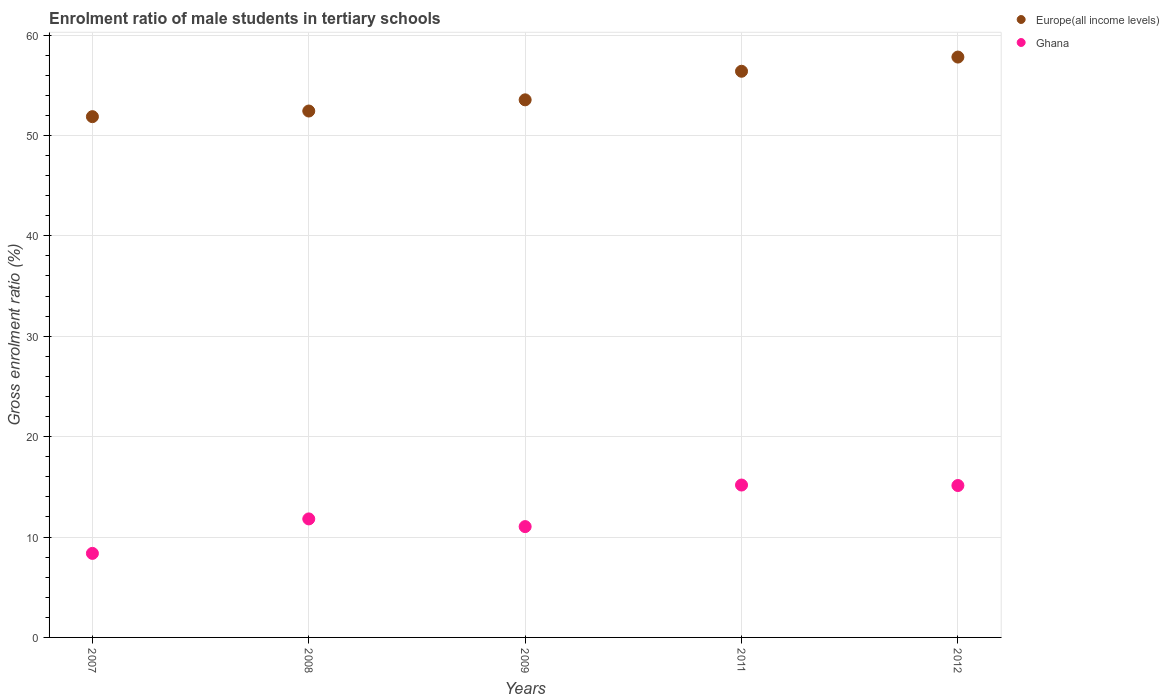What is the enrolment ratio of male students in tertiary schools in Europe(all income levels) in 2011?
Keep it short and to the point. 56.39. Across all years, what is the maximum enrolment ratio of male students in tertiary schools in Europe(all income levels)?
Provide a succinct answer. 57.81. Across all years, what is the minimum enrolment ratio of male students in tertiary schools in Europe(all income levels)?
Make the answer very short. 51.87. In which year was the enrolment ratio of male students in tertiary schools in Europe(all income levels) maximum?
Offer a very short reply. 2012. What is the total enrolment ratio of male students in tertiary schools in Ghana in the graph?
Your answer should be compact. 61.52. What is the difference between the enrolment ratio of male students in tertiary schools in Europe(all income levels) in 2008 and that in 2012?
Provide a succinct answer. -5.37. What is the difference between the enrolment ratio of male students in tertiary schools in Europe(all income levels) in 2009 and the enrolment ratio of male students in tertiary schools in Ghana in 2007?
Provide a short and direct response. 45.18. What is the average enrolment ratio of male students in tertiary schools in Ghana per year?
Provide a short and direct response. 12.3. In the year 2007, what is the difference between the enrolment ratio of male students in tertiary schools in Ghana and enrolment ratio of male students in tertiary schools in Europe(all income levels)?
Your answer should be compact. -43.5. What is the ratio of the enrolment ratio of male students in tertiary schools in Europe(all income levels) in 2007 to that in 2011?
Your answer should be compact. 0.92. What is the difference between the highest and the second highest enrolment ratio of male students in tertiary schools in Europe(all income levels)?
Your response must be concise. 1.41. What is the difference between the highest and the lowest enrolment ratio of male students in tertiary schools in Europe(all income levels)?
Give a very brief answer. 5.94. In how many years, is the enrolment ratio of male students in tertiary schools in Europe(all income levels) greater than the average enrolment ratio of male students in tertiary schools in Europe(all income levels) taken over all years?
Ensure brevity in your answer.  2. Does the enrolment ratio of male students in tertiary schools in Europe(all income levels) monotonically increase over the years?
Keep it short and to the point. Yes. Is the enrolment ratio of male students in tertiary schools in Europe(all income levels) strictly greater than the enrolment ratio of male students in tertiary schools in Ghana over the years?
Keep it short and to the point. Yes. How many dotlines are there?
Your response must be concise. 2. How many years are there in the graph?
Offer a very short reply. 5. Does the graph contain any zero values?
Offer a very short reply. No. Does the graph contain grids?
Your answer should be compact. Yes. Where does the legend appear in the graph?
Give a very brief answer. Top right. How many legend labels are there?
Your answer should be very brief. 2. What is the title of the graph?
Give a very brief answer. Enrolment ratio of male students in tertiary schools. What is the label or title of the X-axis?
Keep it short and to the point. Years. What is the label or title of the Y-axis?
Offer a very short reply. Gross enrolment ratio (%). What is the Gross enrolment ratio (%) of Europe(all income levels) in 2007?
Provide a succinct answer. 51.87. What is the Gross enrolment ratio (%) of Ghana in 2007?
Provide a succinct answer. 8.37. What is the Gross enrolment ratio (%) in Europe(all income levels) in 2008?
Offer a terse response. 52.43. What is the Gross enrolment ratio (%) of Ghana in 2008?
Make the answer very short. 11.8. What is the Gross enrolment ratio (%) in Europe(all income levels) in 2009?
Offer a terse response. 53.55. What is the Gross enrolment ratio (%) in Ghana in 2009?
Offer a very short reply. 11.04. What is the Gross enrolment ratio (%) of Europe(all income levels) in 2011?
Your response must be concise. 56.39. What is the Gross enrolment ratio (%) in Ghana in 2011?
Your answer should be compact. 15.18. What is the Gross enrolment ratio (%) in Europe(all income levels) in 2012?
Offer a very short reply. 57.81. What is the Gross enrolment ratio (%) in Ghana in 2012?
Offer a very short reply. 15.13. Across all years, what is the maximum Gross enrolment ratio (%) in Europe(all income levels)?
Keep it short and to the point. 57.81. Across all years, what is the maximum Gross enrolment ratio (%) in Ghana?
Offer a very short reply. 15.18. Across all years, what is the minimum Gross enrolment ratio (%) in Europe(all income levels)?
Provide a succinct answer. 51.87. Across all years, what is the minimum Gross enrolment ratio (%) in Ghana?
Provide a succinct answer. 8.37. What is the total Gross enrolment ratio (%) in Europe(all income levels) in the graph?
Offer a terse response. 272.05. What is the total Gross enrolment ratio (%) of Ghana in the graph?
Ensure brevity in your answer.  61.52. What is the difference between the Gross enrolment ratio (%) of Europe(all income levels) in 2007 and that in 2008?
Provide a succinct answer. -0.56. What is the difference between the Gross enrolment ratio (%) in Ghana in 2007 and that in 2008?
Your response must be concise. -3.43. What is the difference between the Gross enrolment ratio (%) in Europe(all income levels) in 2007 and that in 2009?
Provide a short and direct response. -1.68. What is the difference between the Gross enrolment ratio (%) in Ghana in 2007 and that in 2009?
Provide a short and direct response. -2.67. What is the difference between the Gross enrolment ratio (%) of Europe(all income levels) in 2007 and that in 2011?
Your answer should be compact. -4.52. What is the difference between the Gross enrolment ratio (%) in Ghana in 2007 and that in 2011?
Provide a short and direct response. -6.81. What is the difference between the Gross enrolment ratio (%) of Europe(all income levels) in 2007 and that in 2012?
Provide a succinct answer. -5.94. What is the difference between the Gross enrolment ratio (%) in Ghana in 2007 and that in 2012?
Your answer should be very brief. -6.76. What is the difference between the Gross enrolment ratio (%) in Europe(all income levels) in 2008 and that in 2009?
Provide a short and direct response. -1.11. What is the difference between the Gross enrolment ratio (%) of Ghana in 2008 and that in 2009?
Keep it short and to the point. 0.77. What is the difference between the Gross enrolment ratio (%) in Europe(all income levels) in 2008 and that in 2011?
Ensure brevity in your answer.  -3.96. What is the difference between the Gross enrolment ratio (%) of Ghana in 2008 and that in 2011?
Provide a short and direct response. -3.37. What is the difference between the Gross enrolment ratio (%) in Europe(all income levels) in 2008 and that in 2012?
Your response must be concise. -5.37. What is the difference between the Gross enrolment ratio (%) of Ghana in 2008 and that in 2012?
Your answer should be very brief. -3.33. What is the difference between the Gross enrolment ratio (%) of Europe(all income levels) in 2009 and that in 2011?
Offer a very short reply. -2.85. What is the difference between the Gross enrolment ratio (%) of Ghana in 2009 and that in 2011?
Provide a succinct answer. -4.14. What is the difference between the Gross enrolment ratio (%) of Europe(all income levels) in 2009 and that in 2012?
Keep it short and to the point. -4.26. What is the difference between the Gross enrolment ratio (%) of Ghana in 2009 and that in 2012?
Your answer should be compact. -4.09. What is the difference between the Gross enrolment ratio (%) in Europe(all income levels) in 2011 and that in 2012?
Make the answer very short. -1.41. What is the difference between the Gross enrolment ratio (%) of Ghana in 2011 and that in 2012?
Your answer should be very brief. 0.05. What is the difference between the Gross enrolment ratio (%) of Europe(all income levels) in 2007 and the Gross enrolment ratio (%) of Ghana in 2008?
Your response must be concise. 40.07. What is the difference between the Gross enrolment ratio (%) of Europe(all income levels) in 2007 and the Gross enrolment ratio (%) of Ghana in 2009?
Provide a succinct answer. 40.83. What is the difference between the Gross enrolment ratio (%) in Europe(all income levels) in 2007 and the Gross enrolment ratio (%) in Ghana in 2011?
Give a very brief answer. 36.69. What is the difference between the Gross enrolment ratio (%) of Europe(all income levels) in 2007 and the Gross enrolment ratio (%) of Ghana in 2012?
Keep it short and to the point. 36.74. What is the difference between the Gross enrolment ratio (%) in Europe(all income levels) in 2008 and the Gross enrolment ratio (%) in Ghana in 2009?
Give a very brief answer. 41.39. What is the difference between the Gross enrolment ratio (%) in Europe(all income levels) in 2008 and the Gross enrolment ratio (%) in Ghana in 2011?
Your answer should be very brief. 37.25. What is the difference between the Gross enrolment ratio (%) of Europe(all income levels) in 2008 and the Gross enrolment ratio (%) of Ghana in 2012?
Your response must be concise. 37.3. What is the difference between the Gross enrolment ratio (%) in Europe(all income levels) in 2009 and the Gross enrolment ratio (%) in Ghana in 2011?
Your answer should be very brief. 38.37. What is the difference between the Gross enrolment ratio (%) of Europe(all income levels) in 2009 and the Gross enrolment ratio (%) of Ghana in 2012?
Make the answer very short. 38.42. What is the difference between the Gross enrolment ratio (%) of Europe(all income levels) in 2011 and the Gross enrolment ratio (%) of Ghana in 2012?
Ensure brevity in your answer.  41.26. What is the average Gross enrolment ratio (%) in Europe(all income levels) per year?
Give a very brief answer. 54.41. What is the average Gross enrolment ratio (%) of Ghana per year?
Ensure brevity in your answer.  12.3. In the year 2007, what is the difference between the Gross enrolment ratio (%) in Europe(all income levels) and Gross enrolment ratio (%) in Ghana?
Offer a terse response. 43.5. In the year 2008, what is the difference between the Gross enrolment ratio (%) in Europe(all income levels) and Gross enrolment ratio (%) in Ghana?
Your answer should be compact. 40.63. In the year 2009, what is the difference between the Gross enrolment ratio (%) in Europe(all income levels) and Gross enrolment ratio (%) in Ghana?
Make the answer very short. 42.51. In the year 2011, what is the difference between the Gross enrolment ratio (%) of Europe(all income levels) and Gross enrolment ratio (%) of Ghana?
Give a very brief answer. 41.21. In the year 2012, what is the difference between the Gross enrolment ratio (%) of Europe(all income levels) and Gross enrolment ratio (%) of Ghana?
Ensure brevity in your answer.  42.68. What is the ratio of the Gross enrolment ratio (%) of Europe(all income levels) in 2007 to that in 2008?
Provide a short and direct response. 0.99. What is the ratio of the Gross enrolment ratio (%) of Ghana in 2007 to that in 2008?
Make the answer very short. 0.71. What is the ratio of the Gross enrolment ratio (%) in Europe(all income levels) in 2007 to that in 2009?
Your response must be concise. 0.97. What is the ratio of the Gross enrolment ratio (%) in Ghana in 2007 to that in 2009?
Your response must be concise. 0.76. What is the ratio of the Gross enrolment ratio (%) of Europe(all income levels) in 2007 to that in 2011?
Provide a short and direct response. 0.92. What is the ratio of the Gross enrolment ratio (%) of Ghana in 2007 to that in 2011?
Ensure brevity in your answer.  0.55. What is the ratio of the Gross enrolment ratio (%) in Europe(all income levels) in 2007 to that in 2012?
Offer a terse response. 0.9. What is the ratio of the Gross enrolment ratio (%) of Ghana in 2007 to that in 2012?
Your response must be concise. 0.55. What is the ratio of the Gross enrolment ratio (%) in Europe(all income levels) in 2008 to that in 2009?
Keep it short and to the point. 0.98. What is the ratio of the Gross enrolment ratio (%) in Ghana in 2008 to that in 2009?
Provide a short and direct response. 1.07. What is the ratio of the Gross enrolment ratio (%) in Europe(all income levels) in 2008 to that in 2011?
Make the answer very short. 0.93. What is the ratio of the Gross enrolment ratio (%) in Ghana in 2008 to that in 2011?
Keep it short and to the point. 0.78. What is the ratio of the Gross enrolment ratio (%) in Europe(all income levels) in 2008 to that in 2012?
Offer a very short reply. 0.91. What is the ratio of the Gross enrolment ratio (%) in Ghana in 2008 to that in 2012?
Provide a short and direct response. 0.78. What is the ratio of the Gross enrolment ratio (%) of Europe(all income levels) in 2009 to that in 2011?
Your answer should be compact. 0.95. What is the ratio of the Gross enrolment ratio (%) of Ghana in 2009 to that in 2011?
Ensure brevity in your answer.  0.73. What is the ratio of the Gross enrolment ratio (%) in Europe(all income levels) in 2009 to that in 2012?
Provide a succinct answer. 0.93. What is the ratio of the Gross enrolment ratio (%) in Ghana in 2009 to that in 2012?
Your answer should be compact. 0.73. What is the ratio of the Gross enrolment ratio (%) of Europe(all income levels) in 2011 to that in 2012?
Give a very brief answer. 0.98. What is the ratio of the Gross enrolment ratio (%) in Ghana in 2011 to that in 2012?
Your answer should be very brief. 1. What is the difference between the highest and the second highest Gross enrolment ratio (%) of Europe(all income levels)?
Your answer should be compact. 1.41. What is the difference between the highest and the second highest Gross enrolment ratio (%) of Ghana?
Your answer should be compact. 0.05. What is the difference between the highest and the lowest Gross enrolment ratio (%) of Europe(all income levels)?
Give a very brief answer. 5.94. What is the difference between the highest and the lowest Gross enrolment ratio (%) of Ghana?
Ensure brevity in your answer.  6.81. 